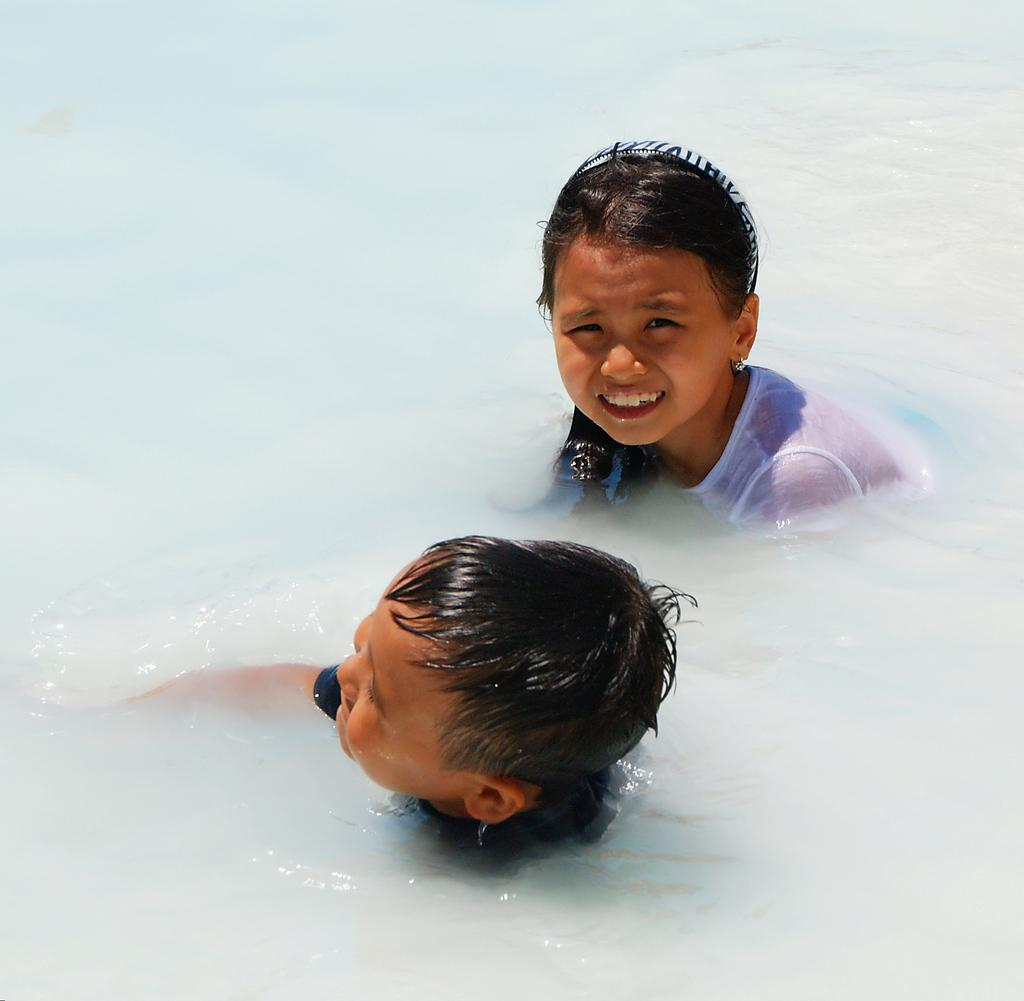What are the kids doing in the image? The kids are in the water. Can you describe the girl's appearance? The girl is wearing a hair band on her head and a white top. Are there any other kids in the image besides the two in the water? No, there are only two kids in the image. What type of berry is the girl holding in the image? There is no berry present in the image; the girl is in the water and wearing a hair band and white top. 